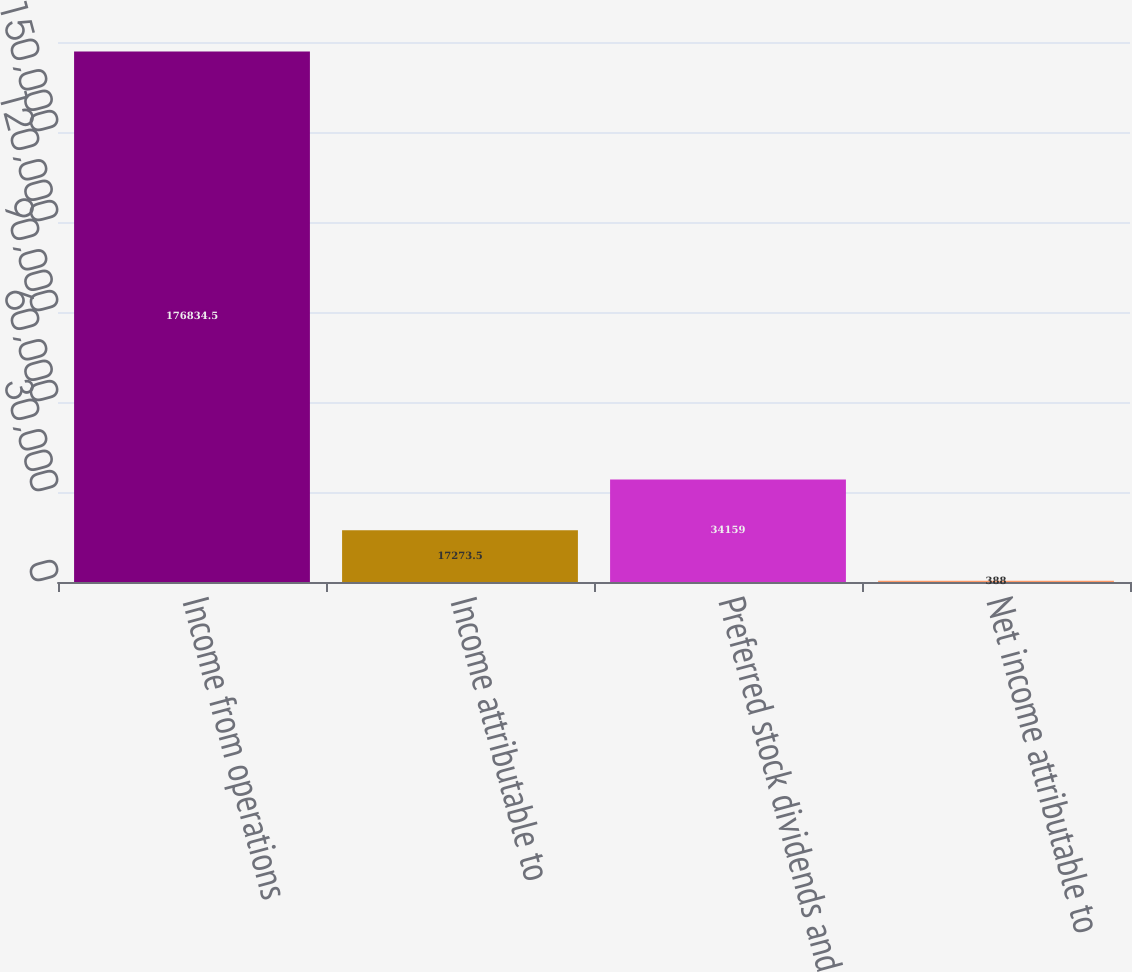Convert chart to OTSL. <chart><loc_0><loc_0><loc_500><loc_500><bar_chart><fcel>Income from operations<fcel>Income attributable to<fcel>Preferred stock dividends and<fcel>Net income attributable to<nl><fcel>176834<fcel>17273.5<fcel>34159<fcel>388<nl></chart> 